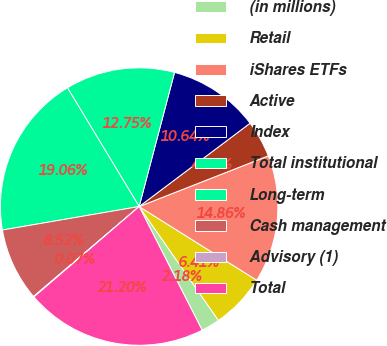Convert chart to OTSL. <chart><loc_0><loc_0><loc_500><loc_500><pie_chart><fcel>(in millions)<fcel>Retail<fcel>iShares ETFs<fcel>Active<fcel>Index<fcel>Total institutional<fcel>Long-term<fcel>Cash management<fcel>Advisory (1)<fcel>Total<nl><fcel>2.18%<fcel>6.41%<fcel>14.86%<fcel>4.3%<fcel>10.64%<fcel>12.75%<fcel>19.06%<fcel>8.52%<fcel>0.07%<fcel>21.2%<nl></chart> 